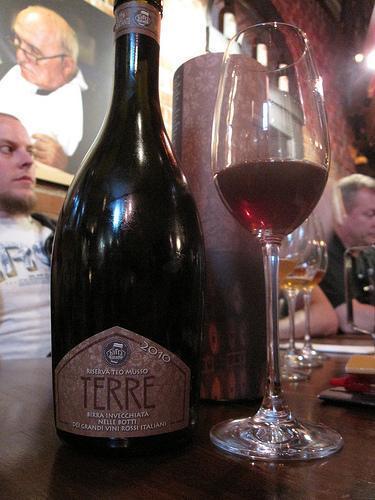How many wine bottles are in the photo?
Give a very brief answer. 1. 